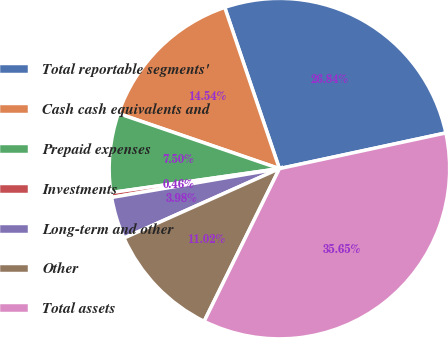<chart> <loc_0><loc_0><loc_500><loc_500><pie_chart><fcel>Total reportable segments'<fcel>Cash cash equivalents and<fcel>Prepaid expenses<fcel>Investments<fcel>Long-term and other<fcel>Other<fcel>Total assets<nl><fcel>26.84%<fcel>14.54%<fcel>7.5%<fcel>0.46%<fcel>3.98%<fcel>11.02%<fcel>35.65%<nl></chart> 